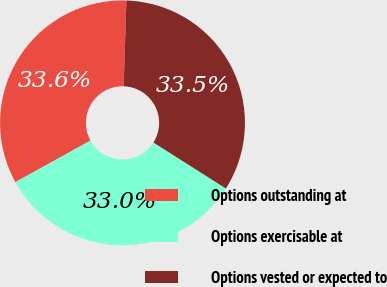<chart> <loc_0><loc_0><loc_500><loc_500><pie_chart><fcel>Options outstanding at<fcel>Options exercisable at<fcel>Options vested or expected to<nl><fcel>33.55%<fcel>32.95%<fcel>33.49%<nl></chart> 